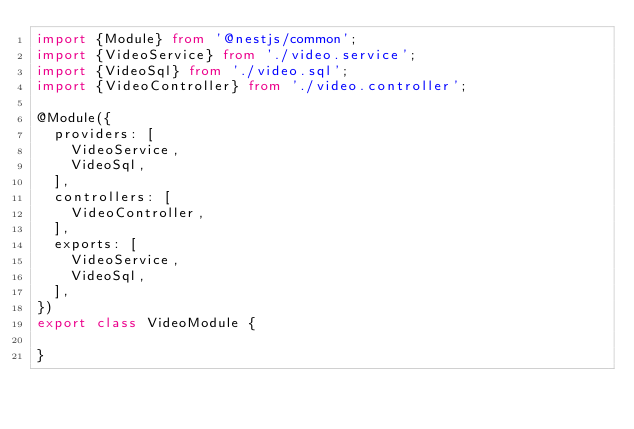<code> <loc_0><loc_0><loc_500><loc_500><_TypeScript_>import {Module} from '@nestjs/common';
import {VideoService} from './video.service';
import {VideoSql} from './video.sql';
import {VideoController} from './video.controller';

@Module({
	providers: [
		VideoService,
		VideoSql,
	],
	controllers: [
		VideoController,
	],
	exports: [
		VideoService,
		VideoSql,
	],
})
export class VideoModule {

}
</code> 